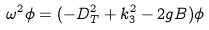Convert formula to latex. <formula><loc_0><loc_0><loc_500><loc_500>\omega ^ { 2 } \phi = ( - D _ { T } ^ { 2 } + k _ { 3 } ^ { 2 } - 2 g B ) \phi</formula> 